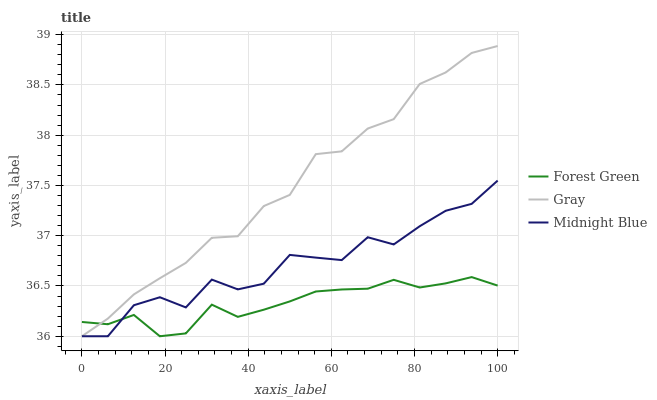Does Forest Green have the minimum area under the curve?
Answer yes or no. Yes. Does Gray have the maximum area under the curve?
Answer yes or no. Yes. Does Midnight Blue have the minimum area under the curve?
Answer yes or no. No. Does Midnight Blue have the maximum area under the curve?
Answer yes or no. No. Is Forest Green the smoothest?
Answer yes or no. Yes. Is Midnight Blue the roughest?
Answer yes or no. Yes. Is Midnight Blue the smoothest?
Answer yes or no. No. Is Forest Green the roughest?
Answer yes or no. No. Does Gray have the highest value?
Answer yes or no. Yes. Does Midnight Blue have the highest value?
Answer yes or no. No. Does Forest Green intersect Midnight Blue?
Answer yes or no. Yes. Is Forest Green less than Midnight Blue?
Answer yes or no. No. Is Forest Green greater than Midnight Blue?
Answer yes or no. No. 